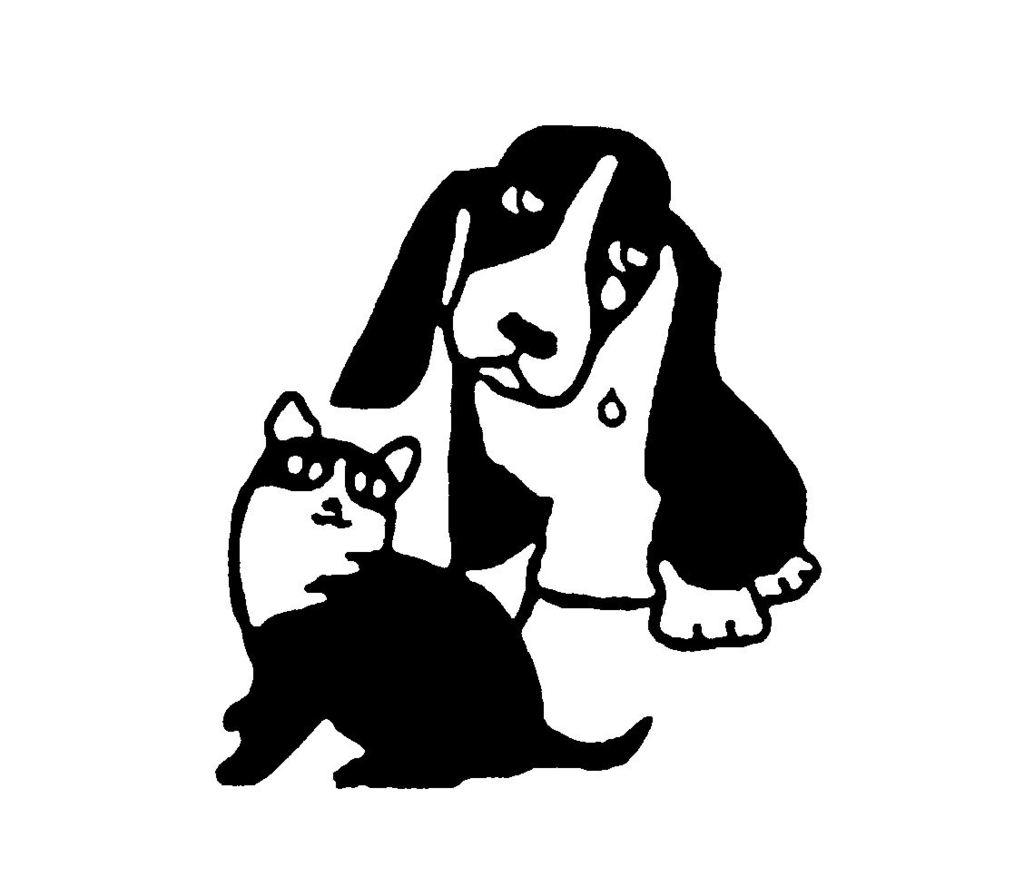What animals are depicted in the image? There is a sketch of a dog and a sketch of a cat in the image. Can you describe the style of the image? The image consists of sketches of the animals. What type of stem can be seen growing from the cat's head in the image? There is no stem growing from the cat's head in the image; it is a sketch of a cat without any additional elements. 